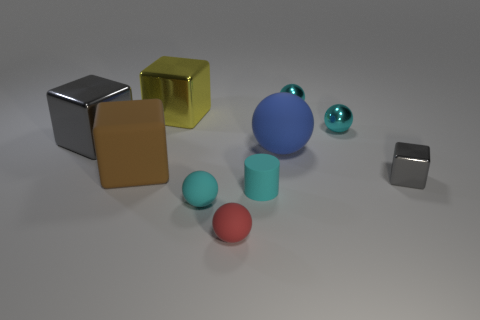Subtract all cyan spheres. How many were subtracted if there are1cyan spheres left? 2 Subtract all purple cubes. How many cyan balls are left? 3 Subtract all red rubber balls. How many balls are left? 4 Subtract all red spheres. How many spheres are left? 4 Subtract all brown spheres. Subtract all blue cubes. How many spheres are left? 5 Subtract all cylinders. How many objects are left? 9 Subtract all tiny cyan shiny objects. Subtract all large blue rubber things. How many objects are left? 7 Add 5 large brown cubes. How many large brown cubes are left? 6 Add 1 tiny brown matte cylinders. How many tiny brown matte cylinders exist? 1 Subtract 0 gray cylinders. How many objects are left? 10 